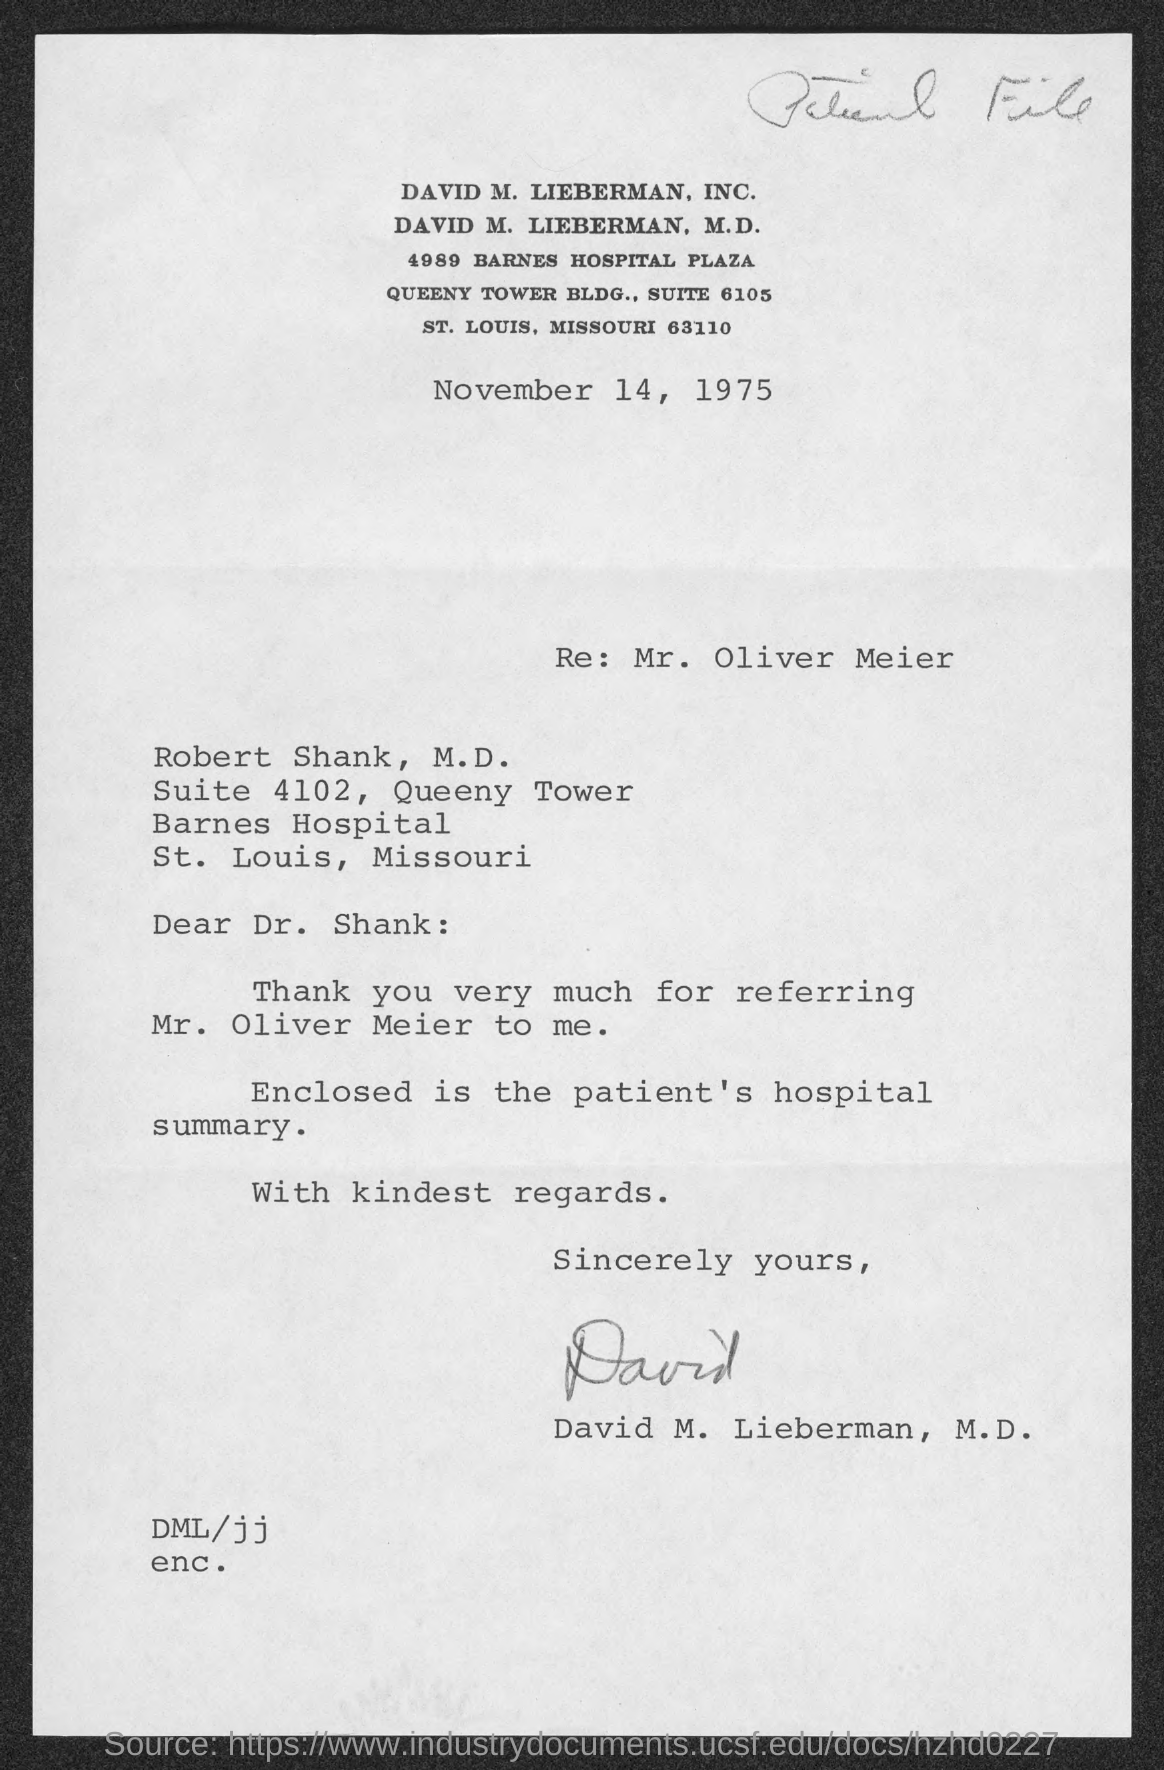What is the date mentioned in document?
Give a very brief answer. November 14, 1975. 